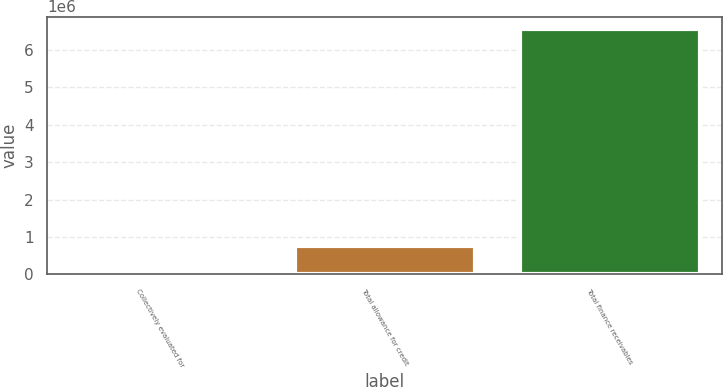Convert chart to OTSL. <chart><loc_0><loc_0><loc_500><loc_500><bar_chart><fcel>Collectively evaluated for<fcel>Total allowance for credit<fcel>Total finance receivables<nl><fcel>127364<fcel>770652<fcel>6.56024e+06<nl></chart> 